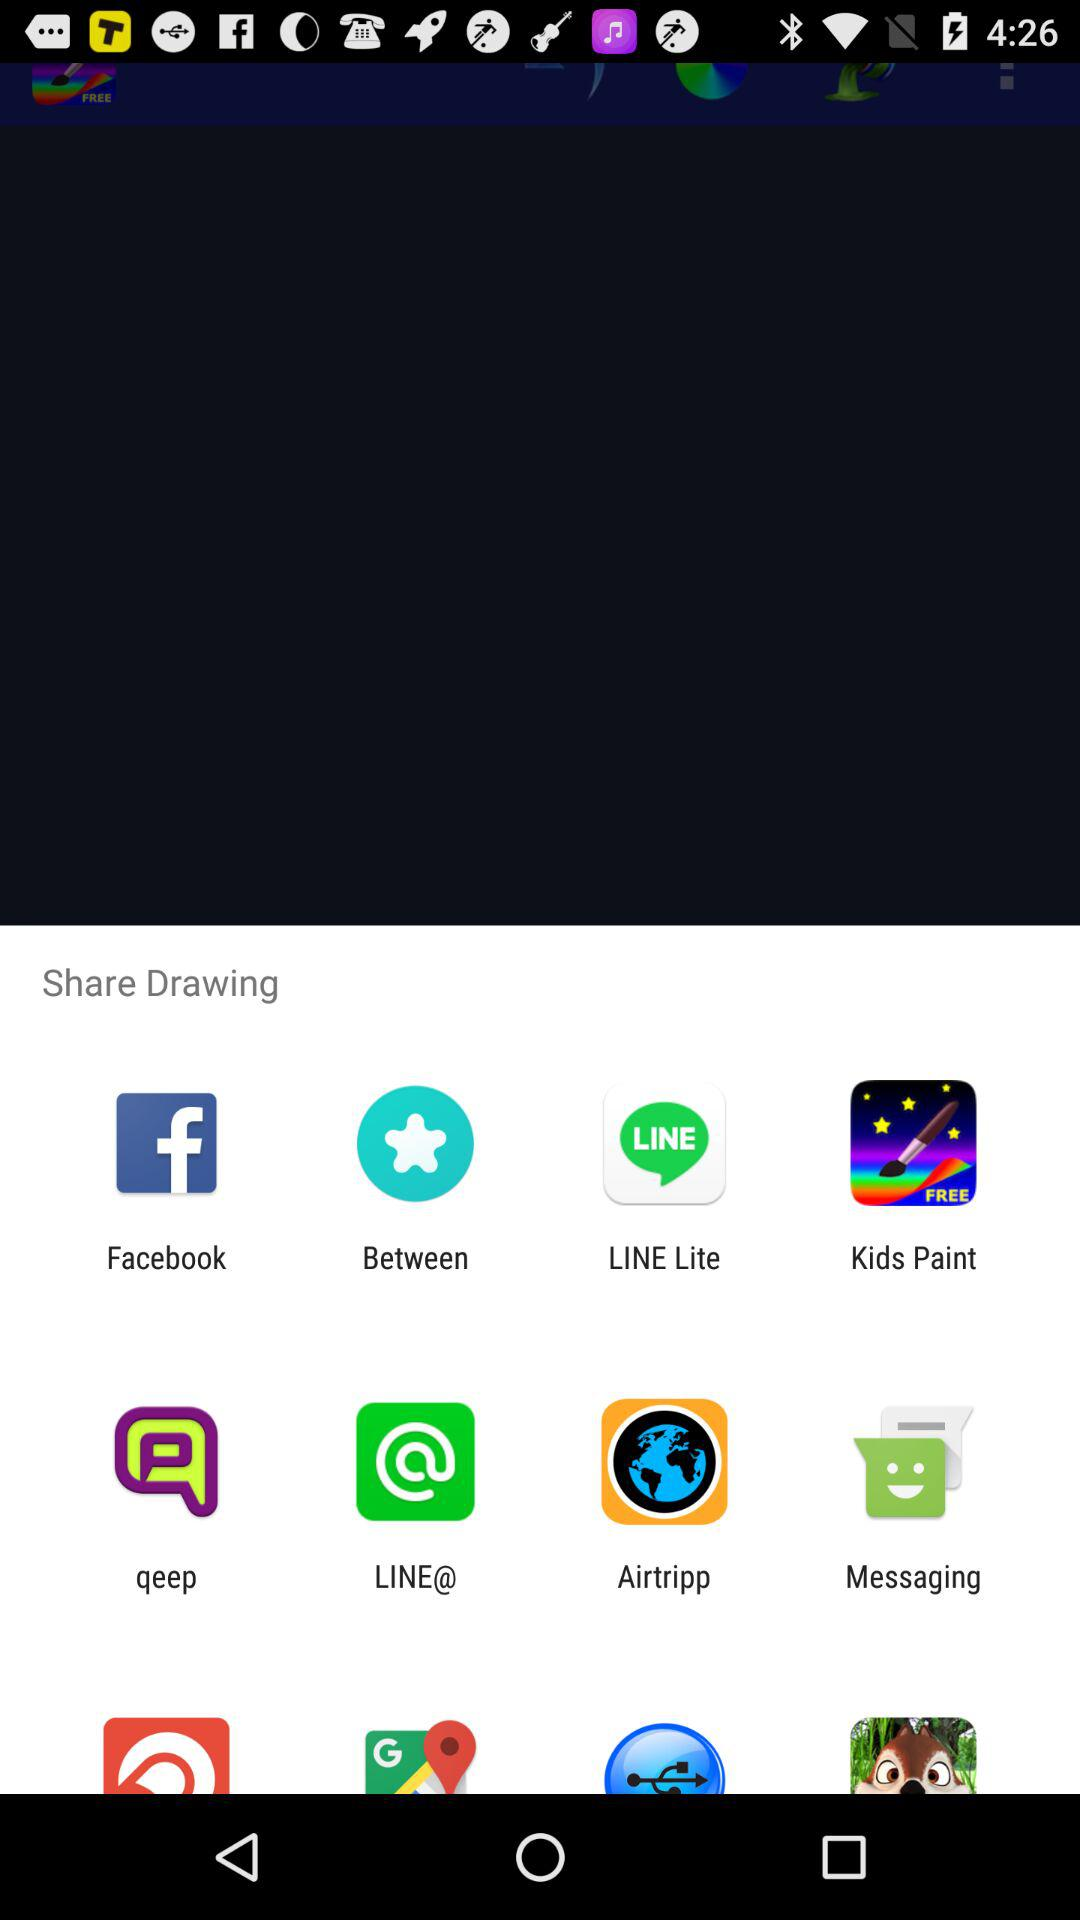Through which application can we share drawings? You can share drawings through "Facebook", "Between", "LINE Lite", "Kids Paint", "qeep", "LINE@", "Airtripp" and "Messaging". 